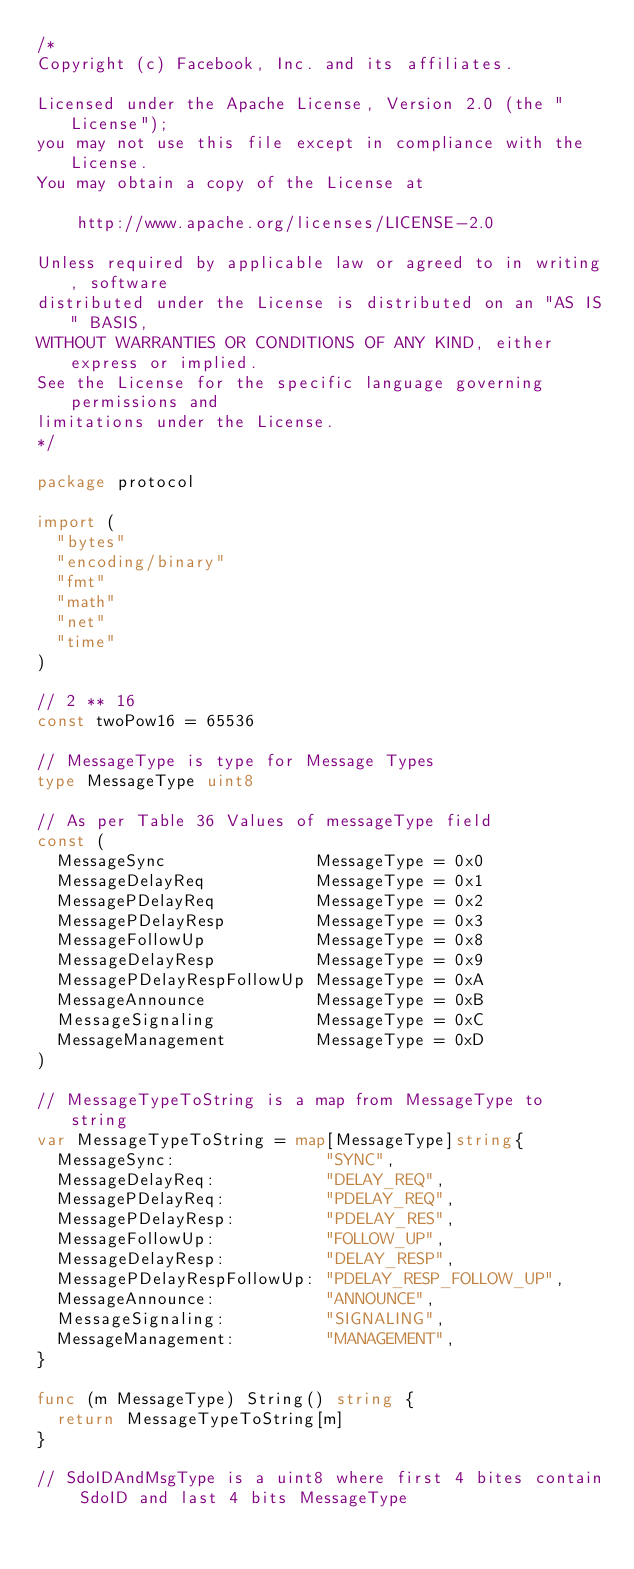Convert code to text. <code><loc_0><loc_0><loc_500><loc_500><_Go_>/*
Copyright (c) Facebook, Inc. and its affiliates.

Licensed under the Apache License, Version 2.0 (the "License");
you may not use this file except in compliance with the License.
You may obtain a copy of the License at

    http://www.apache.org/licenses/LICENSE-2.0

Unless required by applicable law or agreed to in writing, software
distributed under the License is distributed on an "AS IS" BASIS,
WITHOUT WARRANTIES OR CONDITIONS OF ANY KIND, either express or implied.
See the License for the specific language governing permissions and
limitations under the License.
*/

package protocol

import (
	"bytes"
	"encoding/binary"
	"fmt"
	"math"
	"net"
	"time"
)

// 2 ** 16
const twoPow16 = 65536

// MessageType is type for Message Types
type MessageType uint8

// As per Table 36 Values of messageType field
const (
	MessageSync               MessageType = 0x0
	MessageDelayReq           MessageType = 0x1
	MessagePDelayReq          MessageType = 0x2
	MessagePDelayResp         MessageType = 0x3
	MessageFollowUp           MessageType = 0x8
	MessageDelayResp          MessageType = 0x9
	MessagePDelayRespFollowUp MessageType = 0xA
	MessageAnnounce           MessageType = 0xB
	MessageSignaling          MessageType = 0xC
	MessageManagement         MessageType = 0xD
)

// MessageTypeToString is a map from MessageType to string
var MessageTypeToString = map[MessageType]string{
	MessageSync:               "SYNC",
	MessageDelayReq:           "DELAY_REQ",
	MessagePDelayReq:          "PDELAY_REQ",
	MessagePDelayResp:         "PDELAY_RES",
	MessageFollowUp:           "FOLLOW_UP",
	MessageDelayResp:          "DELAY_RESP",
	MessagePDelayRespFollowUp: "PDELAY_RESP_FOLLOW_UP",
	MessageAnnounce:           "ANNOUNCE",
	MessageSignaling:          "SIGNALING",
	MessageManagement:         "MANAGEMENT",
}

func (m MessageType) String() string {
	return MessageTypeToString[m]
}

// SdoIDAndMsgType is a uint8 where first 4 bites contain SdoID and last 4 bits MessageType</code> 